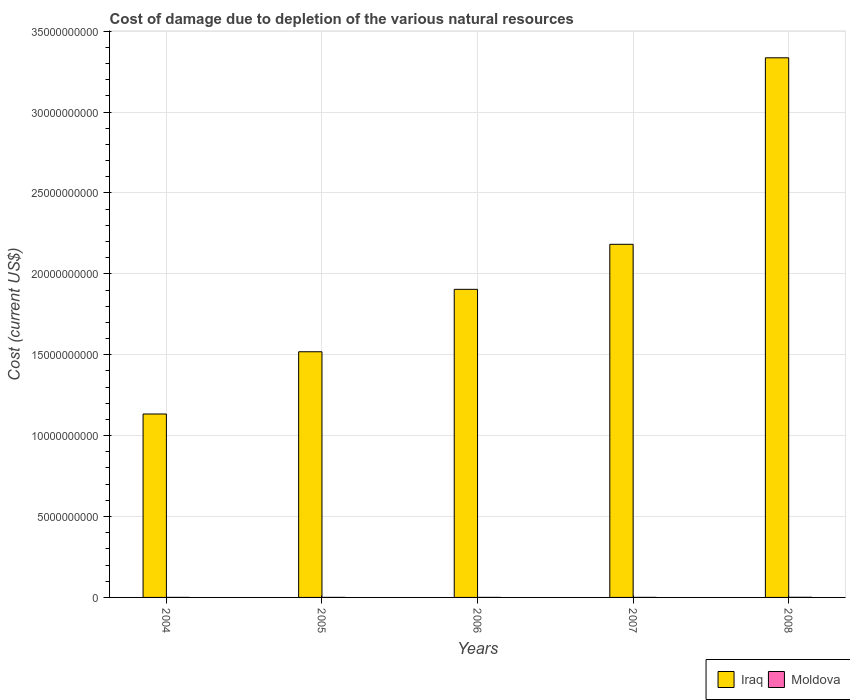How many different coloured bars are there?
Keep it short and to the point. 2. How many groups of bars are there?
Make the answer very short. 5. Are the number of bars on each tick of the X-axis equal?
Ensure brevity in your answer.  Yes. How many bars are there on the 3rd tick from the left?
Ensure brevity in your answer.  2. In how many cases, is the number of bars for a given year not equal to the number of legend labels?
Your answer should be compact. 0. What is the cost of damage caused due to the depletion of various natural resources in Iraq in 2008?
Make the answer very short. 3.34e+1. Across all years, what is the maximum cost of damage caused due to the depletion of various natural resources in Moldova?
Offer a very short reply. 7.20e+06. Across all years, what is the minimum cost of damage caused due to the depletion of various natural resources in Iraq?
Ensure brevity in your answer.  1.13e+1. In which year was the cost of damage caused due to the depletion of various natural resources in Moldova maximum?
Provide a succinct answer. 2008. What is the total cost of damage caused due to the depletion of various natural resources in Iraq in the graph?
Offer a terse response. 1.01e+11. What is the difference between the cost of damage caused due to the depletion of various natural resources in Iraq in 2005 and that in 2007?
Provide a short and direct response. -6.64e+09. What is the difference between the cost of damage caused due to the depletion of various natural resources in Iraq in 2005 and the cost of damage caused due to the depletion of various natural resources in Moldova in 2006?
Provide a short and direct response. 1.52e+1. What is the average cost of damage caused due to the depletion of various natural resources in Moldova per year?
Provide a short and direct response. 2.80e+06. In the year 2007, what is the difference between the cost of damage caused due to the depletion of various natural resources in Iraq and cost of damage caused due to the depletion of various natural resources in Moldova?
Offer a very short reply. 2.18e+1. What is the ratio of the cost of damage caused due to the depletion of various natural resources in Iraq in 2007 to that in 2008?
Give a very brief answer. 0.65. Is the cost of damage caused due to the depletion of various natural resources in Moldova in 2006 less than that in 2008?
Make the answer very short. Yes. What is the difference between the highest and the second highest cost of damage caused due to the depletion of various natural resources in Iraq?
Your answer should be compact. 1.15e+1. What is the difference between the highest and the lowest cost of damage caused due to the depletion of various natural resources in Iraq?
Offer a very short reply. 2.20e+1. Is the sum of the cost of damage caused due to the depletion of various natural resources in Iraq in 2005 and 2007 greater than the maximum cost of damage caused due to the depletion of various natural resources in Moldova across all years?
Your answer should be very brief. Yes. What does the 1st bar from the left in 2008 represents?
Your answer should be compact. Iraq. What does the 1st bar from the right in 2008 represents?
Your answer should be very brief. Moldova. How many bars are there?
Ensure brevity in your answer.  10. Are the values on the major ticks of Y-axis written in scientific E-notation?
Offer a very short reply. No. Does the graph contain any zero values?
Give a very brief answer. No. Does the graph contain grids?
Make the answer very short. Yes. How are the legend labels stacked?
Your answer should be compact. Horizontal. What is the title of the graph?
Make the answer very short. Cost of damage due to depletion of the various natural resources. Does "Poland" appear as one of the legend labels in the graph?
Offer a very short reply. No. What is the label or title of the X-axis?
Ensure brevity in your answer.  Years. What is the label or title of the Y-axis?
Make the answer very short. Cost (current US$). What is the Cost (current US$) in Iraq in 2004?
Your answer should be very brief. 1.13e+1. What is the Cost (current US$) in Moldova in 2004?
Your response must be concise. 1.45e+06. What is the Cost (current US$) in Iraq in 2005?
Ensure brevity in your answer.  1.52e+1. What is the Cost (current US$) in Moldova in 2005?
Your answer should be compact. 1.31e+06. What is the Cost (current US$) of Iraq in 2006?
Offer a terse response. 1.90e+1. What is the Cost (current US$) in Moldova in 2006?
Provide a succinct answer. 1.27e+06. What is the Cost (current US$) of Iraq in 2007?
Offer a terse response. 2.18e+1. What is the Cost (current US$) of Moldova in 2007?
Provide a succinct answer. 2.79e+06. What is the Cost (current US$) in Iraq in 2008?
Your response must be concise. 3.34e+1. What is the Cost (current US$) in Moldova in 2008?
Your response must be concise. 7.20e+06. Across all years, what is the maximum Cost (current US$) in Iraq?
Offer a very short reply. 3.34e+1. Across all years, what is the maximum Cost (current US$) of Moldova?
Your answer should be compact. 7.20e+06. Across all years, what is the minimum Cost (current US$) of Iraq?
Give a very brief answer. 1.13e+1. Across all years, what is the minimum Cost (current US$) of Moldova?
Make the answer very short. 1.27e+06. What is the total Cost (current US$) of Iraq in the graph?
Provide a short and direct response. 1.01e+11. What is the total Cost (current US$) of Moldova in the graph?
Offer a terse response. 1.40e+07. What is the difference between the Cost (current US$) in Iraq in 2004 and that in 2005?
Provide a short and direct response. -3.85e+09. What is the difference between the Cost (current US$) of Moldova in 2004 and that in 2005?
Make the answer very short. 1.41e+05. What is the difference between the Cost (current US$) of Iraq in 2004 and that in 2006?
Keep it short and to the point. -7.71e+09. What is the difference between the Cost (current US$) in Moldova in 2004 and that in 2006?
Offer a terse response. 1.81e+05. What is the difference between the Cost (current US$) in Iraq in 2004 and that in 2007?
Your answer should be very brief. -1.05e+1. What is the difference between the Cost (current US$) in Moldova in 2004 and that in 2007?
Keep it short and to the point. -1.34e+06. What is the difference between the Cost (current US$) of Iraq in 2004 and that in 2008?
Provide a succinct answer. -2.20e+1. What is the difference between the Cost (current US$) in Moldova in 2004 and that in 2008?
Keep it short and to the point. -5.76e+06. What is the difference between the Cost (current US$) of Iraq in 2005 and that in 2006?
Your answer should be very brief. -3.86e+09. What is the difference between the Cost (current US$) of Moldova in 2005 and that in 2006?
Your answer should be very brief. 3.91e+04. What is the difference between the Cost (current US$) in Iraq in 2005 and that in 2007?
Provide a succinct answer. -6.64e+09. What is the difference between the Cost (current US$) of Moldova in 2005 and that in 2007?
Offer a terse response. -1.48e+06. What is the difference between the Cost (current US$) of Iraq in 2005 and that in 2008?
Your answer should be very brief. -1.82e+1. What is the difference between the Cost (current US$) of Moldova in 2005 and that in 2008?
Your answer should be compact. -5.90e+06. What is the difference between the Cost (current US$) of Iraq in 2006 and that in 2007?
Ensure brevity in your answer.  -2.78e+09. What is the difference between the Cost (current US$) of Moldova in 2006 and that in 2007?
Give a very brief answer. -1.52e+06. What is the difference between the Cost (current US$) of Iraq in 2006 and that in 2008?
Offer a very short reply. -1.43e+1. What is the difference between the Cost (current US$) in Moldova in 2006 and that in 2008?
Your answer should be compact. -5.94e+06. What is the difference between the Cost (current US$) in Iraq in 2007 and that in 2008?
Ensure brevity in your answer.  -1.15e+1. What is the difference between the Cost (current US$) in Moldova in 2007 and that in 2008?
Keep it short and to the point. -4.42e+06. What is the difference between the Cost (current US$) of Iraq in 2004 and the Cost (current US$) of Moldova in 2005?
Provide a short and direct response. 1.13e+1. What is the difference between the Cost (current US$) of Iraq in 2004 and the Cost (current US$) of Moldova in 2006?
Provide a short and direct response. 1.13e+1. What is the difference between the Cost (current US$) of Iraq in 2004 and the Cost (current US$) of Moldova in 2007?
Provide a short and direct response. 1.13e+1. What is the difference between the Cost (current US$) in Iraq in 2004 and the Cost (current US$) in Moldova in 2008?
Provide a short and direct response. 1.13e+1. What is the difference between the Cost (current US$) of Iraq in 2005 and the Cost (current US$) of Moldova in 2006?
Ensure brevity in your answer.  1.52e+1. What is the difference between the Cost (current US$) of Iraq in 2005 and the Cost (current US$) of Moldova in 2007?
Your response must be concise. 1.52e+1. What is the difference between the Cost (current US$) in Iraq in 2005 and the Cost (current US$) in Moldova in 2008?
Your answer should be very brief. 1.52e+1. What is the difference between the Cost (current US$) of Iraq in 2006 and the Cost (current US$) of Moldova in 2007?
Make the answer very short. 1.90e+1. What is the difference between the Cost (current US$) in Iraq in 2006 and the Cost (current US$) in Moldova in 2008?
Your response must be concise. 1.90e+1. What is the difference between the Cost (current US$) in Iraq in 2007 and the Cost (current US$) in Moldova in 2008?
Keep it short and to the point. 2.18e+1. What is the average Cost (current US$) of Iraq per year?
Offer a terse response. 2.01e+1. What is the average Cost (current US$) of Moldova per year?
Your response must be concise. 2.80e+06. In the year 2004, what is the difference between the Cost (current US$) in Iraq and Cost (current US$) in Moldova?
Offer a terse response. 1.13e+1. In the year 2005, what is the difference between the Cost (current US$) of Iraq and Cost (current US$) of Moldova?
Provide a short and direct response. 1.52e+1. In the year 2006, what is the difference between the Cost (current US$) in Iraq and Cost (current US$) in Moldova?
Make the answer very short. 1.90e+1. In the year 2007, what is the difference between the Cost (current US$) in Iraq and Cost (current US$) in Moldova?
Ensure brevity in your answer.  2.18e+1. In the year 2008, what is the difference between the Cost (current US$) of Iraq and Cost (current US$) of Moldova?
Give a very brief answer. 3.33e+1. What is the ratio of the Cost (current US$) in Iraq in 2004 to that in 2005?
Your response must be concise. 0.75. What is the ratio of the Cost (current US$) in Moldova in 2004 to that in 2005?
Provide a short and direct response. 1.11. What is the ratio of the Cost (current US$) of Iraq in 2004 to that in 2006?
Ensure brevity in your answer.  0.6. What is the ratio of the Cost (current US$) in Moldova in 2004 to that in 2006?
Your answer should be compact. 1.14. What is the ratio of the Cost (current US$) of Iraq in 2004 to that in 2007?
Provide a succinct answer. 0.52. What is the ratio of the Cost (current US$) of Moldova in 2004 to that in 2007?
Offer a very short reply. 0.52. What is the ratio of the Cost (current US$) of Iraq in 2004 to that in 2008?
Your response must be concise. 0.34. What is the ratio of the Cost (current US$) of Moldova in 2004 to that in 2008?
Your answer should be very brief. 0.2. What is the ratio of the Cost (current US$) of Iraq in 2005 to that in 2006?
Give a very brief answer. 0.8. What is the ratio of the Cost (current US$) in Moldova in 2005 to that in 2006?
Your response must be concise. 1.03. What is the ratio of the Cost (current US$) of Iraq in 2005 to that in 2007?
Your response must be concise. 0.7. What is the ratio of the Cost (current US$) in Moldova in 2005 to that in 2007?
Your answer should be very brief. 0.47. What is the ratio of the Cost (current US$) in Iraq in 2005 to that in 2008?
Ensure brevity in your answer.  0.46. What is the ratio of the Cost (current US$) in Moldova in 2005 to that in 2008?
Ensure brevity in your answer.  0.18. What is the ratio of the Cost (current US$) of Iraq in 2006 to that in 2007?
Your answer should be very brief. 0.87. What is the ratio of the Cost (current US$) in Moldova in 2006 to that in 2007?
Offer a terse response. 0.45. What is the ratio of the Cost (current US$) in Iraq in 2006 to that in 2008?
Provide a succinct answer. 0.57. What is the ratio of the Cost (current US$) of Moldova in 2006 to that in 2008?
Keep it short and to the point. 0.18. What is the ratio of the Cost (current US$) of Iraq in 2007 to that in 2008?
Provide a succinct answer. 0.65. What is the ratio of the Cost (current US$) in Moldova in 2007 to that in 2008?
Keep it short and to the point. 0.39. What is the difference between the highest and the second highest Cost (current US$) of Iraq?
Make the answer very short. 1.15e+1. What is the difference between the highest and the second highest Cost (current US$) of Moldova?
Give a very brief answer. 4.42e+06. What is the difference between the highest and the lowest Cost (current US$) of Iraq?
Offer a very short reply. 2.20e+1. What is the difference between the highest and the lowest Cost (current US$) of Moldova?
Your answer should be compact. 5.94e+06. 